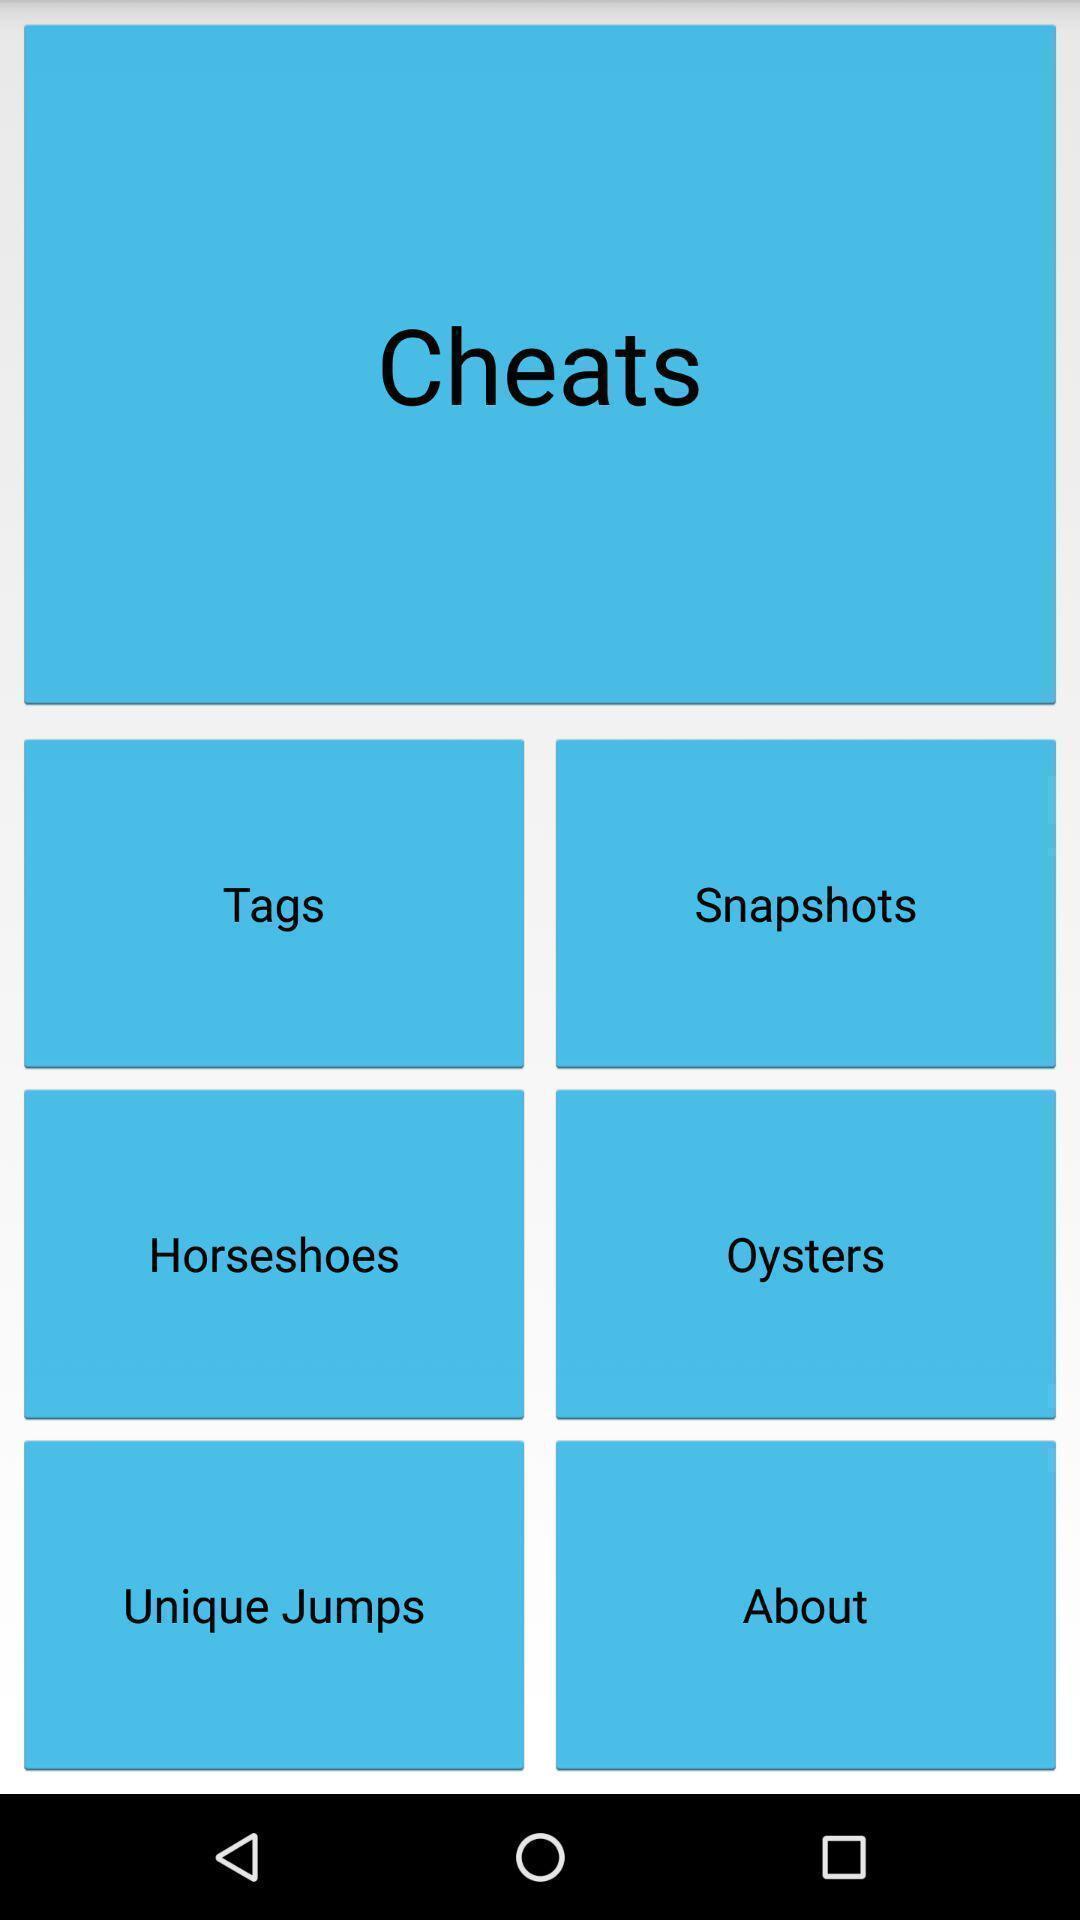Summarize the main components in this picture. Page displaying information about gallery. 